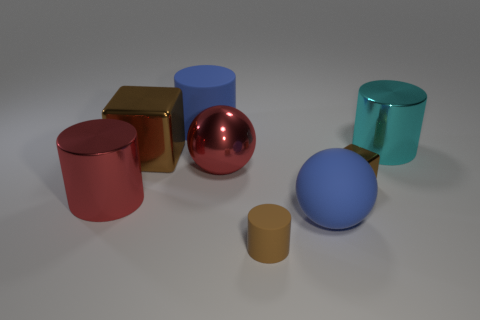Add 1 green metallic balls. How many objects exist? 9 Subtract all cyan metal cylinders. How many cylinders are left? 3 Subtract all cyan cylinders. How many cylinders are left? 3 Add 4 blue spheres. How many blue spheres exist? 5 Subtract 0 purple cylinders. How many objects are left? 8 Subtract all cubes. How many objects are left? 6 Subtract 1 spheres. How many spheres are left? 1 Subtract all purple cylinders. Subtract all red balls. How many cylinders are left? 4 Subtract all red shiny balls. Subtract all red shiny things. How many objects are left? 5 Add 6 large cyan metallic objects. How many large cyan metallic objects are left? 7 